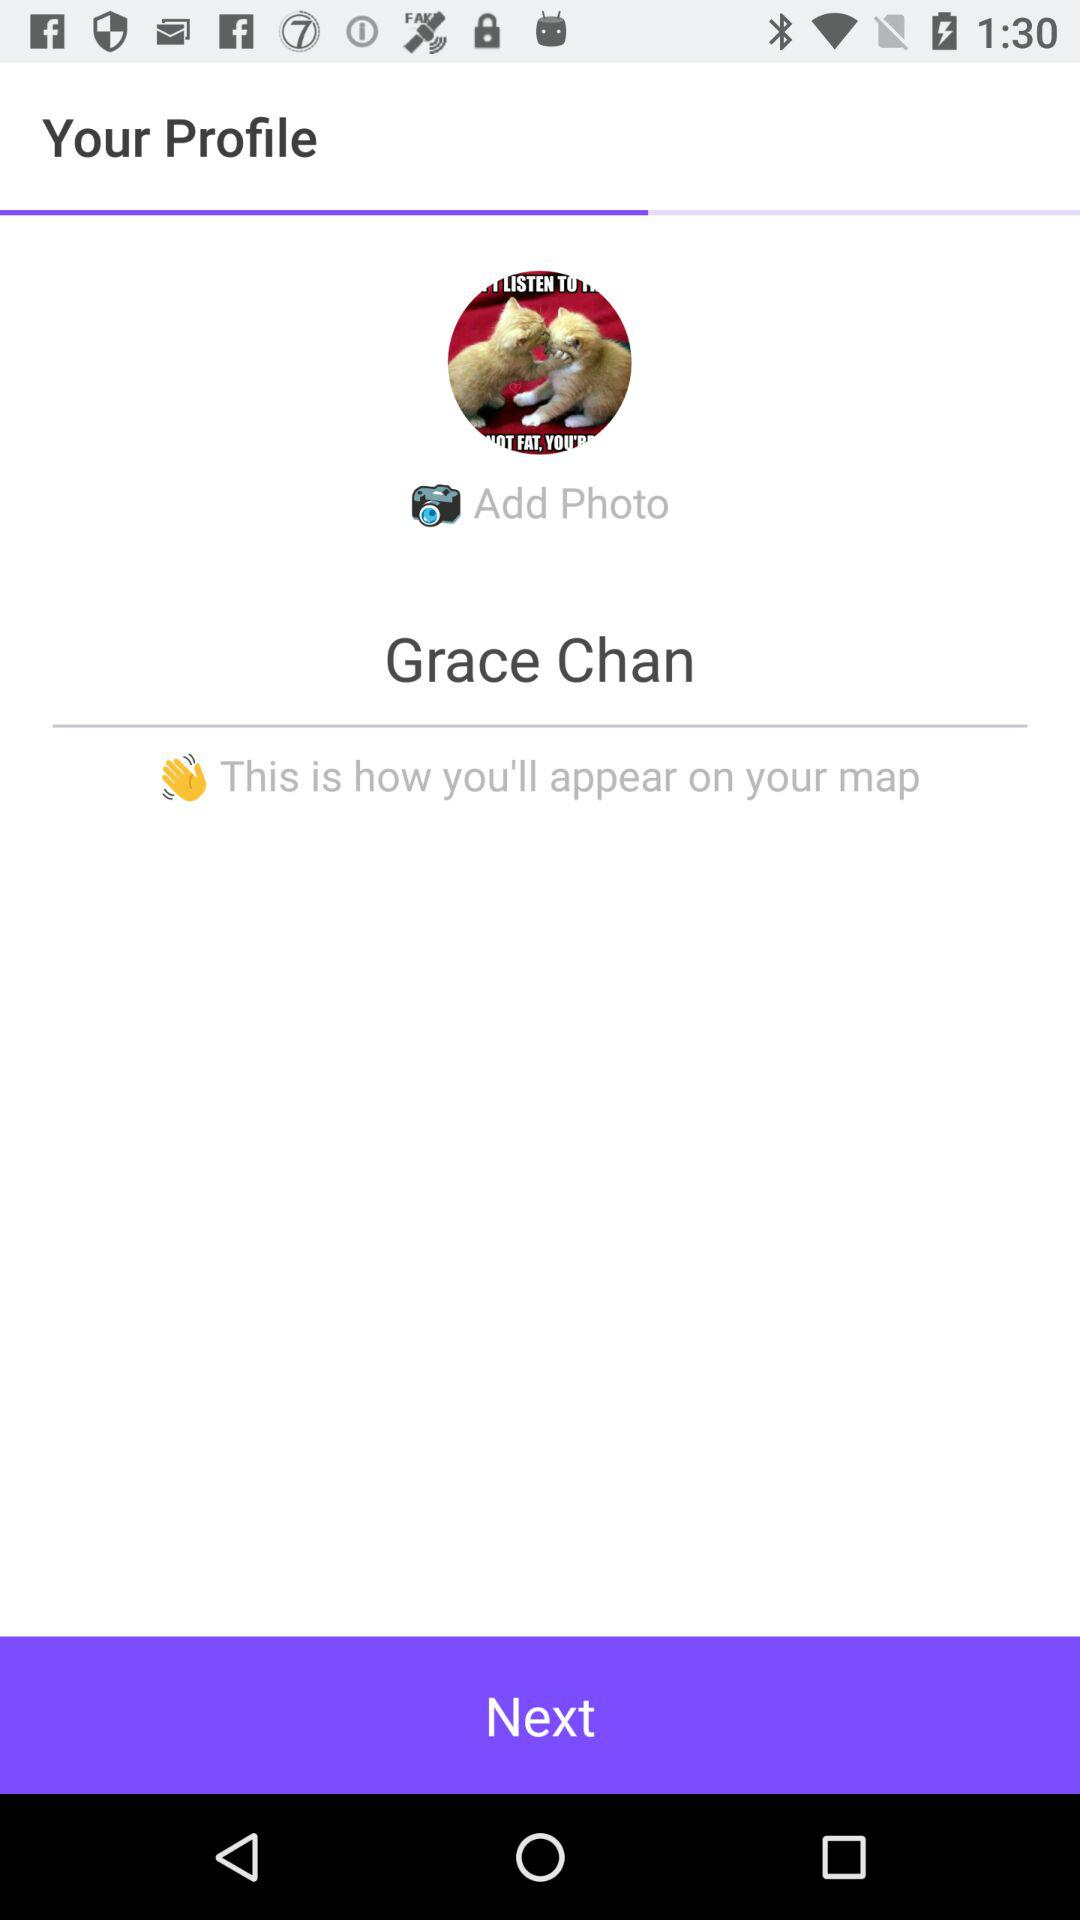What is the user name? The user name is Grace Chan. 